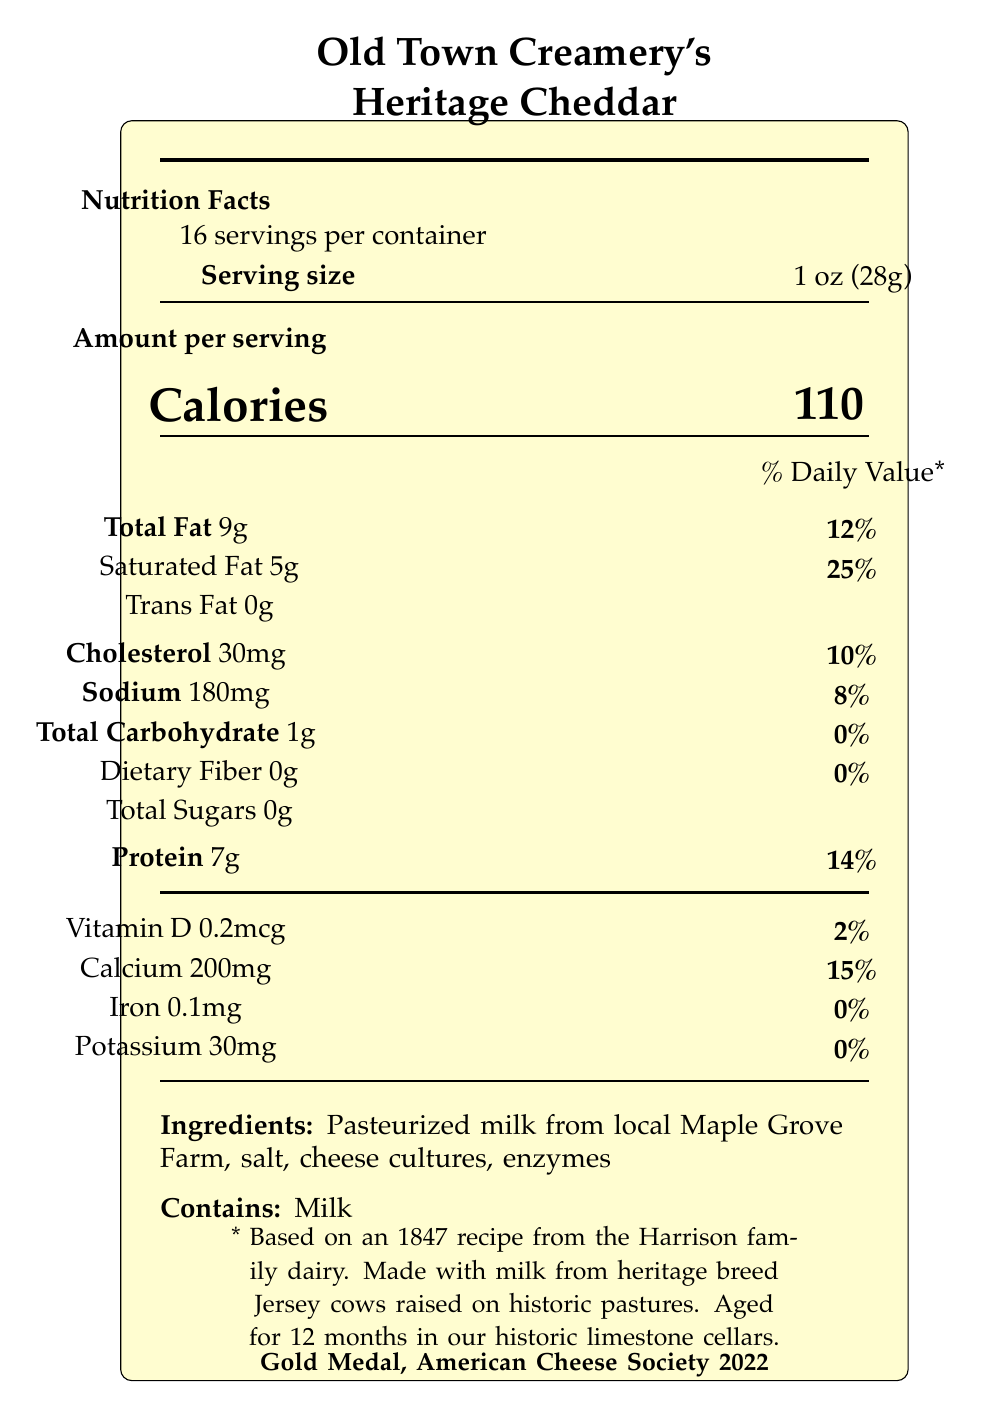What is the serving size of Old Town Creamery's Heritage Cheddar? The serving size is clearly indicated as "1 oz (28g)" in the document.
Answer: 1 oz (28g) How many calories are there per serving of the cheese? The document states that there are 110 calories per serving.
Answer: 110 What is the amount of protein per serving? The protein content per serving is listed as 7g.
Answer: 7g What percentage of the daily value for calcium does a serving of this cheese provide? The document indicates that each serving provides 15% of the daily value for calcium.
Answer: 15% What is the total fat content per serving? The total fat content per serving is 9g, as specified in the document.
Answer: 9g What ingredients are used in this cheese? The ingredients listed in the document are pasteurized milk from local Maple Grove Farm, salt, cheese cultures, and enzymes.
Answer: Pasteurized milk from local Maple Grove Farm, salt, cheese cultures, enzymes What historic element is included in the cheese's recipe? The document mentions that the cheese is based on an 1847 recipe from the Harrison family dairy.
Answer: Based on an 1847 recipe from the Harrison family dairy How long is the cheese aged? The cheese is aged for 12 months, according to the document.
Answer: 12 months How many servings are there in a container? The document states that there are 16 servings per container.
Answer: 16 Which allergens are present in this cheese? The document mentions that the cheese contains milk as an allergen.
Answer: Contains milk What award did Old Town Creamery's Heritage Cheddar win and in what year? The document states that the cheese won the Gold Medal at the American Cheese Society in 2022.
Answer: Gold Medal, American Cheese Society 2022 Which local farm provides the milk for this cheese? The milk used in the cheese comes from local Maple Grove Farm.
Answer: Maple Grove Farm Which of the following nutrients is NOT present in significant amounts in the cheese? A. Vitamin D B. Iron C. Potassium D. All of the above The document shows very low values for Vitamin D, Iron, and Potassium, making all three options correct.
Answer: D. All of the above What is the percentage of daily value for saturated fat in one serving? The document specifies that one serving contains 25% of the daily value for saturated fat.
Answer: 25% Does Old Town Creamery's Heritage Cheddar contain any dietary fiber? The document indicates that the cheese contains 0g of dietary fiber.
Answer: No Summarize the main idea of the nutrition facts label for Old Town Creamery's Heritage Cheddar. The document provides detailed nutritional information, ingredient lists, and notable historical and regional facts, underscoring the cheese's heritage and quality.
Answer: Old Town Creamery's Heritage Cheddar is a locally-sourced artisanal cheese with a rich history, including a recipe dating back to 1847. It is made from milk from heritage breed Jersey cows, aged for 12 months, and has won a Gold Medal from the American Cheese Society in 2022. The nutrition facts include details on calories, fat, protein, vitamins, and minerals per serving. How does the aging process of Old Town Creamery's Heritage Cheddar contribute to its regional significance? The document mentions that the cheese is aged for 12 months in historic limestone cellars, but it does not specify how this contributes to its regional significance.
Answer: Cannot be determined Is the packaging of the cheese environmentally friendly? The document notes that the packaging is made from 100% recycled materials, indicating it is environmentally friendly.
Answer: Yes 